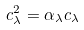Convert formula to latex. <formula><loc_0><loc_0><loc_500><loc_500>c _ { \lambda } ^ { 2 } = \alpha _ { \lambda } c _ { \lambda }</formula> 